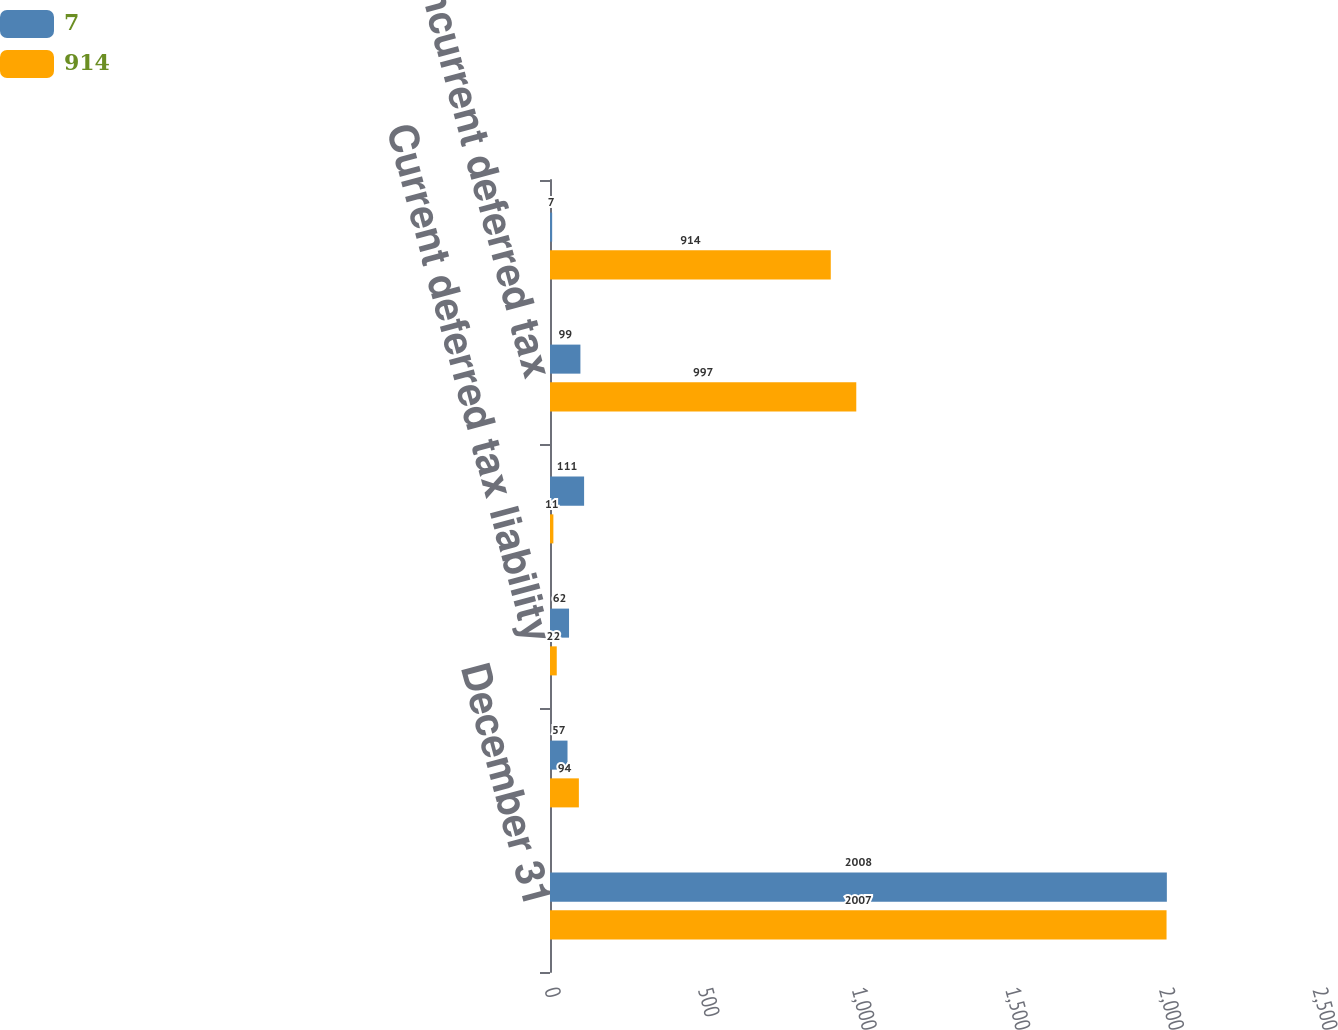Convert chart. <chart><loc_0><loc_0><loc_500><loc_500><stacked_bar_chart><ecel><fcel>December 31<fcel>Current deferred tax asset<fcel>Current deferred tax liability<fcel>Noncurrent deferred tax asset<fcel>Noncurrent deferred tax<fcel>Net deferred tax asset<nl><fcel>7<fcel>2008<fcel>57<fcel>62<fcel>111<fcel>99<fcel>7<nl><fcel>914<fcel>2007<fcel>94<fcel>22<fcel>11<fcel>997<fcel>914<nl></chart> 